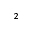Convert formula to latex. <formula><loc_0><loc_0><loc_500><loc_500>^ { 2 }</formula> 